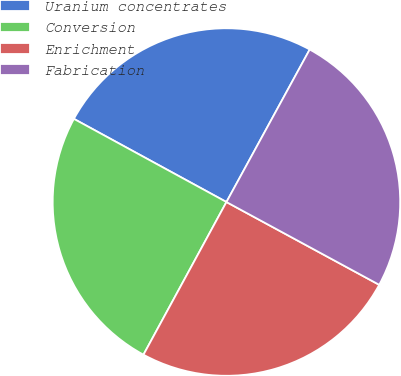Convert chart to OTSL. <chart><loc_0><loc_0><loc_500><loc_500><pie_chart><fcel>Uranium concentrates<fcel>Conversion<fcel>Enrichment<fcel>Fabrication<nl><fcel>25.01%<fcel>25.02%<fcel>25.02%<fcel>24.95%<nl></chart> 